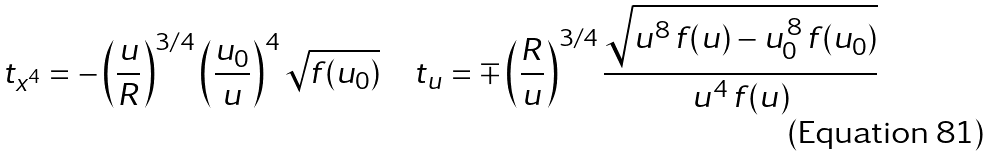<formula> <loc_0><loc_0><loc_500><loc_500>t _ { x ^ { 4 } } = - \left ( \frac { u } { R } \right ) ^ { 3 / 4 } \left ( \frac { u _ { 0 } } { u } \right ) ^ { 4 } \sqrt { f ( u _ { 0 } ) } \quad t _ { u } = \mp \left ( \frac { R } { u } \right ) ^ { 3 / 4 } \frac { \sqrt { u ^ { 8 } \, f ( u ) - u _ { 0 } ^ { \, 8 } \, f ( u _ { 0 } ) } } { u ^ { 4 } \, f ( u ) }</formula> 